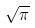<formula> <loc_0><loc_0><loc_500><loc_500>\sqrt { \pi }</formula> 